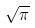<formula> <loc_0><loc_0><loc_500><loc_500>\sqrt { \pi }</formula> 